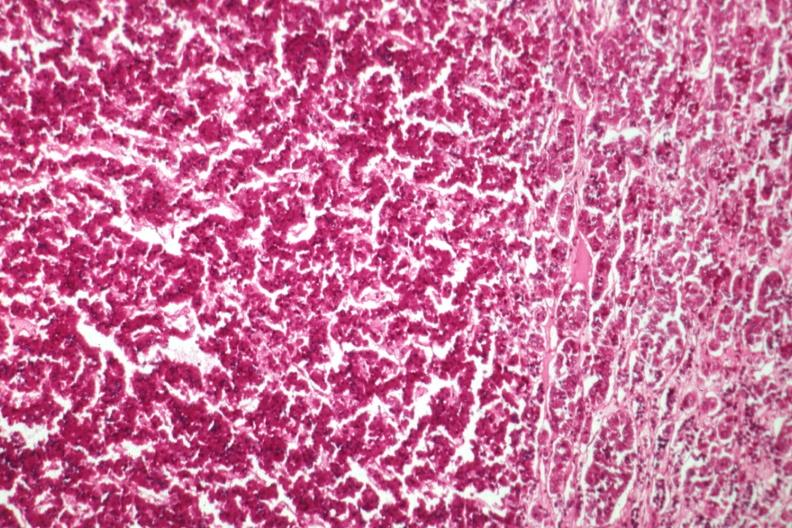where is this part in the figure?
Answer the question using a single word or phrase. Endocrine system 